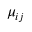Convert formula to latex. <formula><loc_0><loc_0><loc_500><loc_500>\mu _ { i j }</formula> 